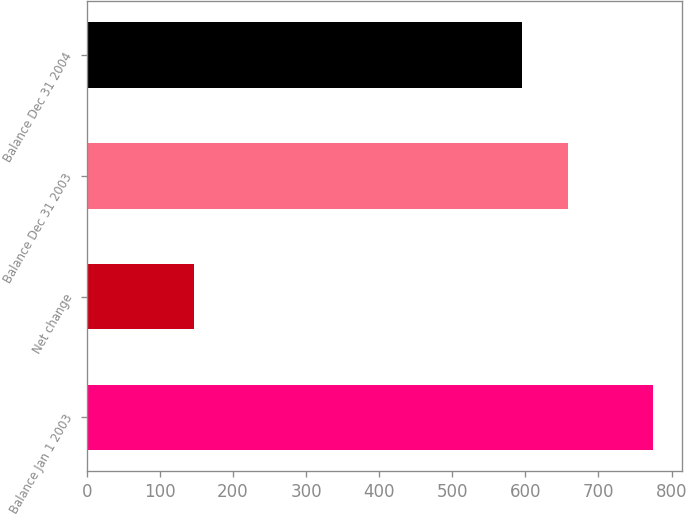Convert chart to OTSL. <chart><loc_0><loc_0><loc_500><loc_500><bar_chart><fcel>Balance Jan 1 2003<fcel>Net change<fcel>Balance Dec 31 2003<fcel>Balance Dec 31 2004<nl><fcel>775<fcel>147<fcel>657.8<fcel>595<nl></chart> 